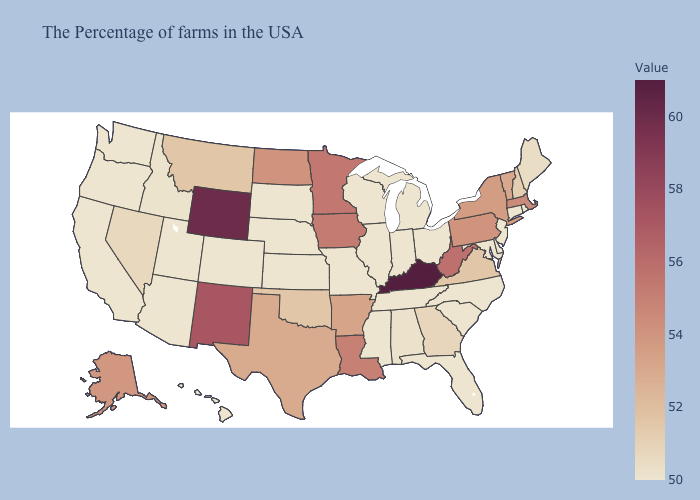Does Kentucky have the highest value in the USA?
Be succinct. Yes. Which states have the lowest value in the Northeast?
Write a very short answer. Rhode Island, Connecticut, New Jersey. Which states have the lowest value in the USA?
Concise answer only. Rhode Island, Connecticut, New Jersey, Delaware, Maryland, North Carolina, South Carolina, Ohio, Florida, Michigan, Indiana, Tennessee, Wisconsin, Illinois, Mississippi, Missouri, Kansas, Nebraska, South Dakota, Colorado, Utah, Arizona, California, Washington, Oregon, Hawaii. Which states have the lowest value in the West?
Quick response, please. Colorado, Utah, Arizona, California, Washington, Oregon, Hawaii. 